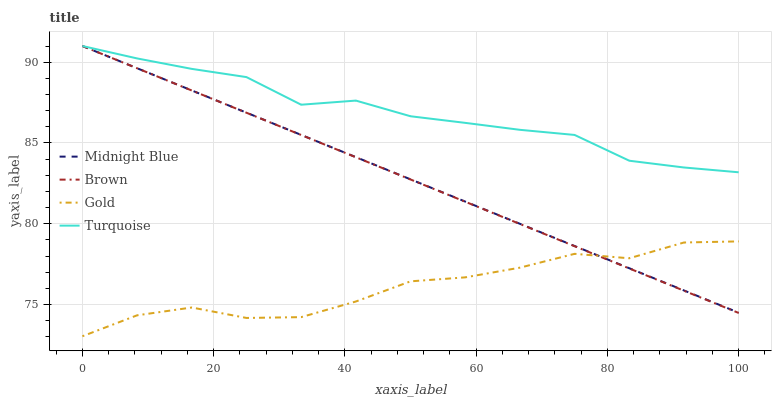Does Gold have the minimum area under the curve?
Answer yes or no. Yes. Does Turquoise have the maximum area under the curve?
Answer yes or no. Yes. Does Midnight Blue have the minimum area under the curve?
Answer yes or no. No. Does Midnight Blue have the maximum area under the curve?
Answer yes or no. No. Is Brown the smoothest?
Answer yes or no. Yes. Is Gold the roughest?
Answer yes or no. Yes. Is Turquoise the smoothest?
Answer yes or no. No. Is Turquoise the roughest?
Answer yes or no. No. Does Gold have the lowest value?
Answer yes or no. Yes. Does Midnight Blue have the lowest value?
Answer yes or no. No. Does Midnight Blue have the highest value?
Answer yes or no. Yes. Does Gold have the highest value?
Answer yes or no. No. Is Gold less than Turquoise?
Answer yes or no. Yes. Is Turquoise greater than Gold?
Answer yes or no. Yes. Does Gold intersect Brown?
Answer yes or no. Yes. Is Gold less than Brown?
Answer yes or no. No. Is Gold greater than Brown?
Answer yes or no. No. Does Gold intersect Turquoise?
Answer yes or no. No. 